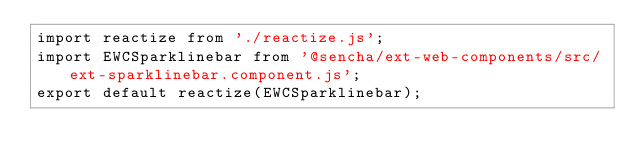<code> <loc_0><loc_0><loc_500><loc_500><_JavaScript_>import reactize from './reactize.js';
import EWCSparklinebar from '@sencha/ext-web-components/src/ext-sparklinebar.component.js';
export default reactize(EWCSparklinebar);
</code> 